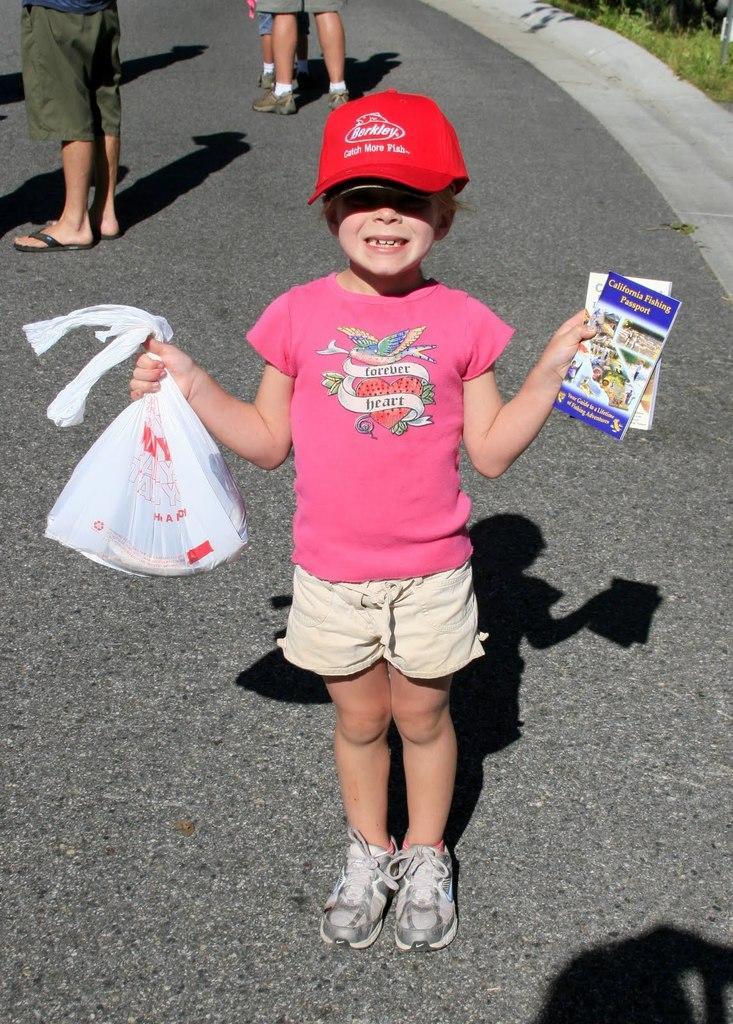Please provide a concise description of this image. In this picture there is a girl who is wearing cap, t-shirt, short and shoes. She is holding a plastic cover and books. At the top I can see the person's leg who is wearing short and shoes. In the top left corner I can see another person's leg who is wearing short and sleepers. Beside him I can see other person's shadow on the road. In the top right corner I can see the plants and grass. 